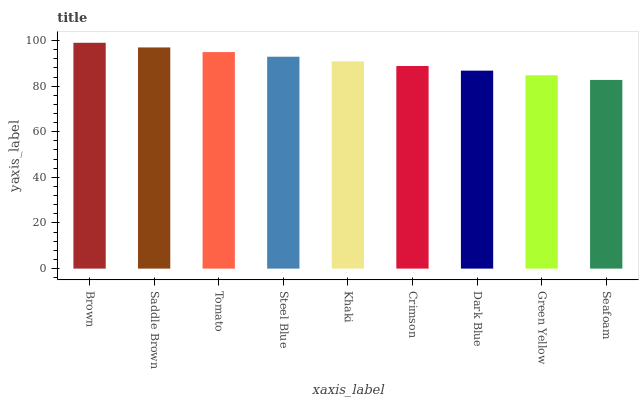Is Saddle Brown the minimum?
Answer yes or no. No. Is Saddle Brown the maximum?
Answer yes or no. No. Is Brown greater than Saddle Brown?
Answer yes or no. Yes. Is Saddle Brown less than Brown?
Answer yes or no. Yes. Is Saddle Brown greater than Brown?
Answer yes or no. No. Is Brown less than Saddle Brown?
Answer yes or no. No. Is Khaki the high median?
Answer yes or no. Yes. Is Khaki the low median?
Answer yes or no. Yes. Is Saddle Brown the high median?
Answer yes or no. No. Is Dark Blue the low median?
Answer yes or no. No. 